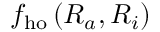Convert formula to latex. <formula><loc_0><loc_0><loc_500><loc_500>f _ { h o } \left ( R _ { a } , R _ { i } \right )</formula> 